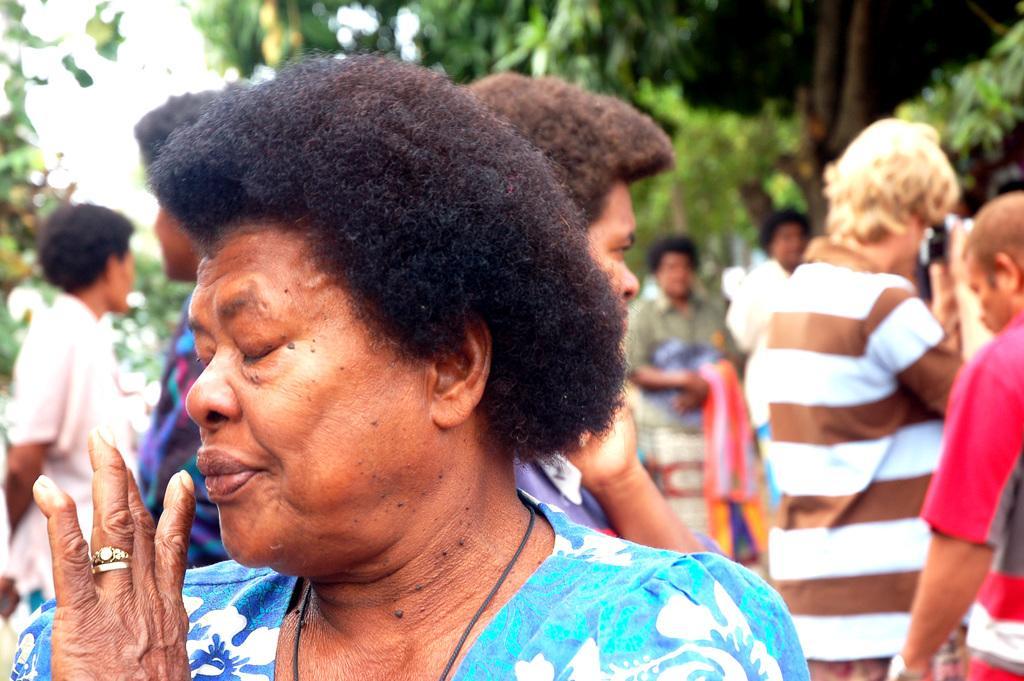Describe this image in one or two sentences. This image consists of a woman wearing blue dress. In the background, there are many people. And there are trees. 